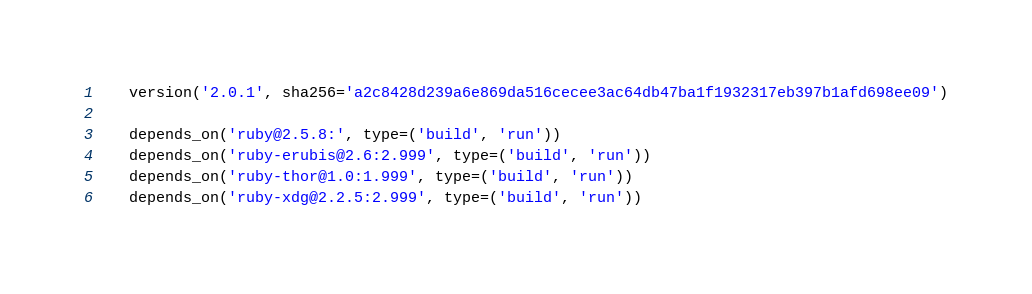<code> <loc_0><loc_0><loc_500><loc_500><_Python_>    version('2.0.1', sha256='a2c8428d239a6e869da516cecee3ac64db47ba1f1932317eb397b1afd698ee09')

    depends_on('ruby@2.5.8:', type=('build', 'run'))
    depends_on('ruby-erubis@2.6:2.999', type=('build', 'run'))
    depends_on('ruby-thor@1.0:1.999', type=('build', 'run'))
    depends_on('ruby-xdg@2.2.5:2.999', type=('build', 'run'))
</code> 